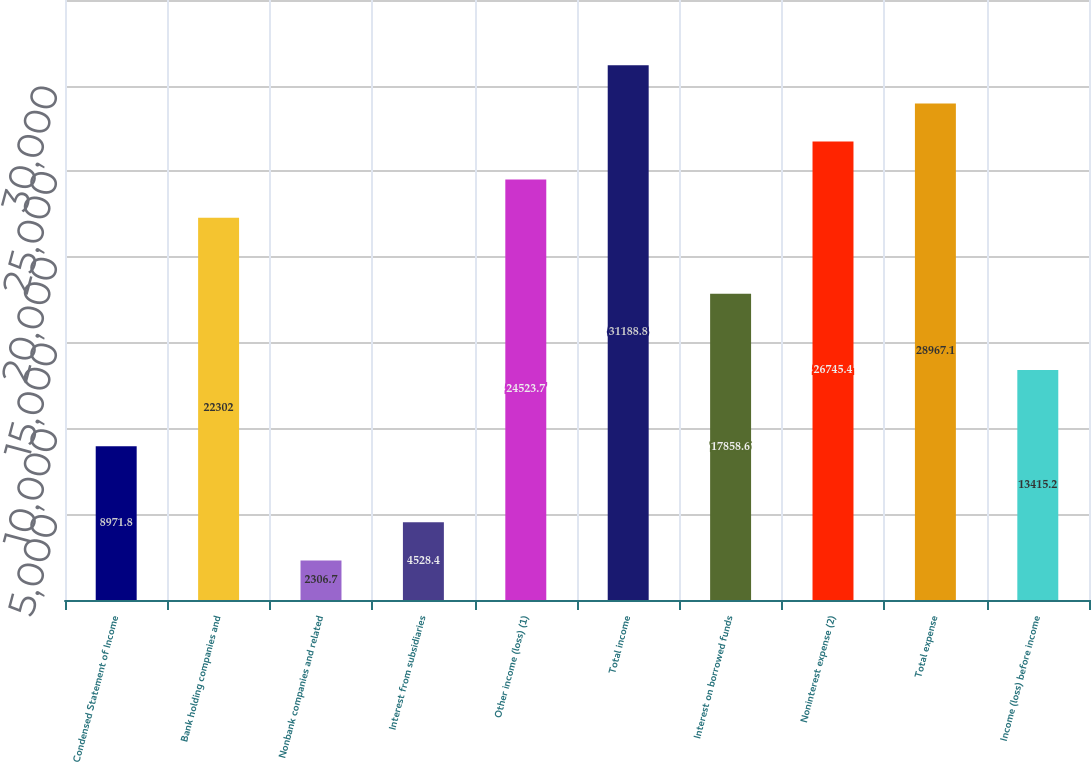Convert chart to OTSL. <chart><loc_0><loc_0><loc_500><loc_500><bar_chart><fcel>Condensed Statement of Income<fcel>Bank holding companies and<fcel>Nonbank companies and related<fcel>Interest from subsidiaries<fcel>Other income (loss) (1)<fcel>Total income<fcel>Interest on borrowed funds<fcel>Noninterest expense (2)<fcel>Total expense<fcel>Income (loss) before income<nl><fcel>8971.8<fcel>22302<fcel>2306.7<fcel>4528.4<fcel>24523.7<fcel>31188.8<fcel>17858.6<fcel>26745.4<fcel>28967.1<fcel>13415.2<nl></chart> 